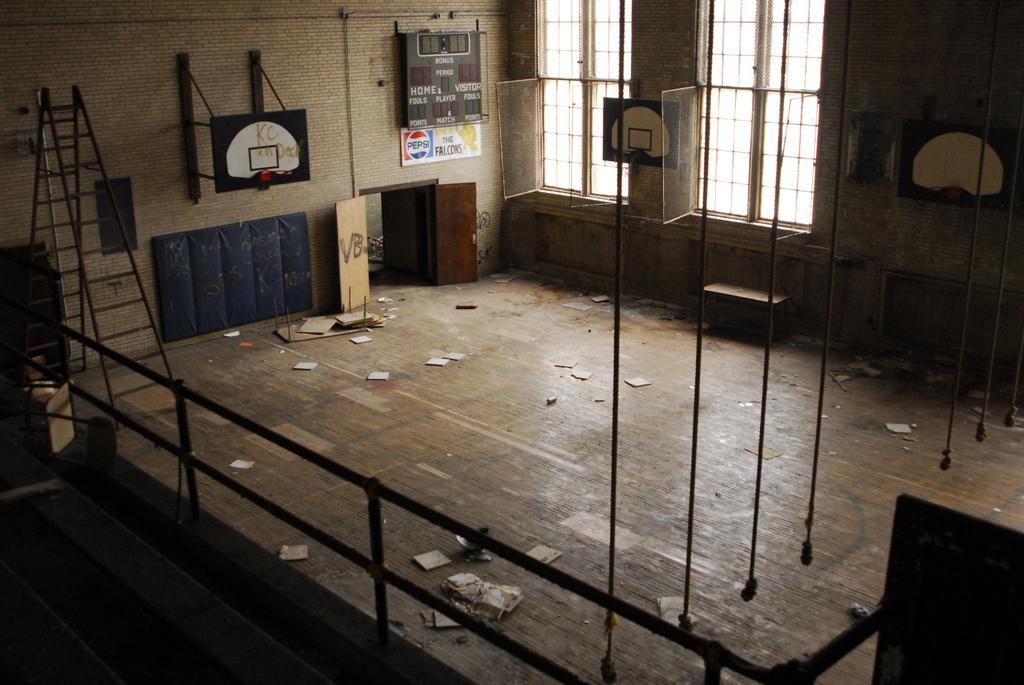Could you give a brief overview of what you see in this image? In this image I can see the inner part of the house. Inside the house I can see few ropes hanging. To the left I can see the ladder. I can also see many boards and windows to the wall. I can see many papers on the wooden floor. 